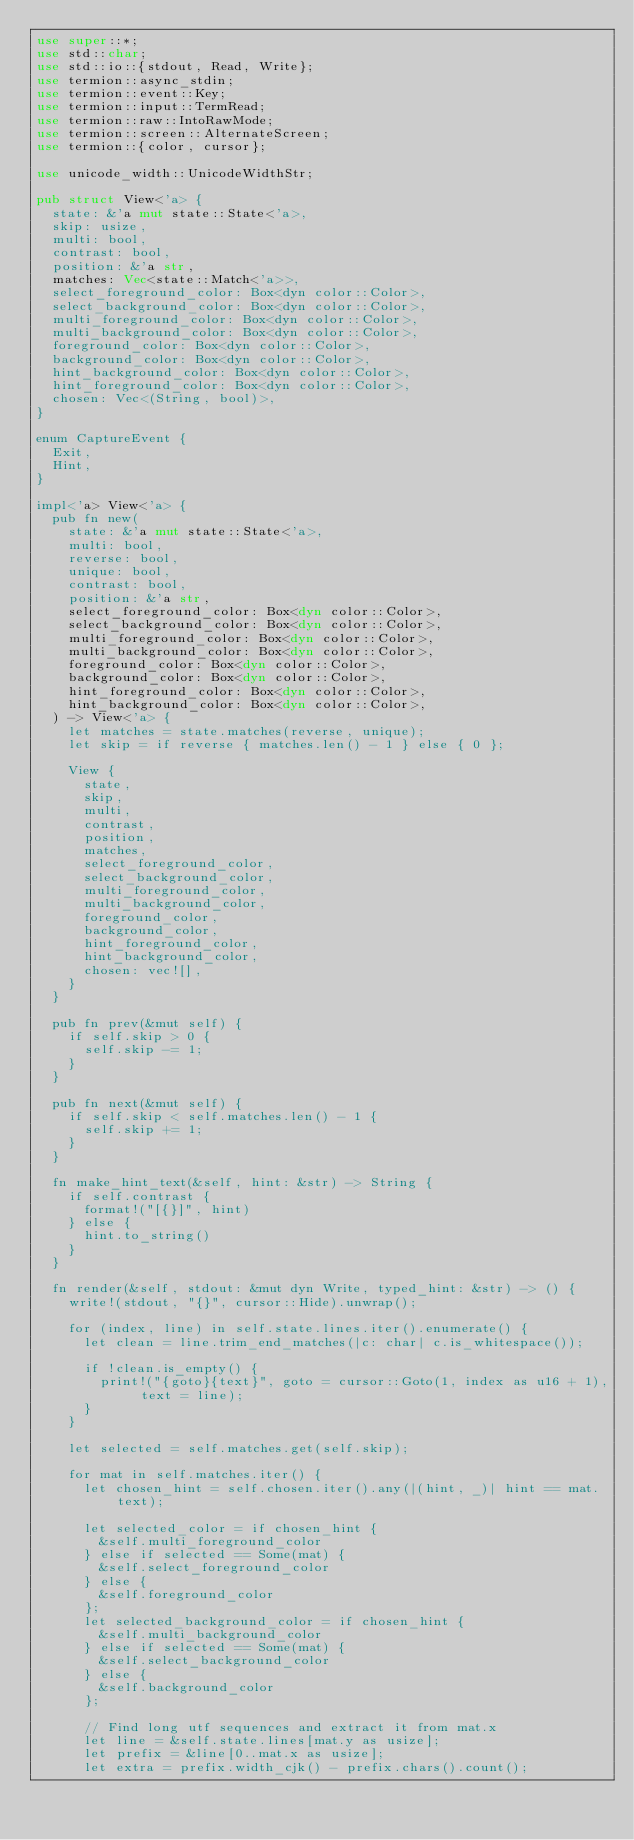<code> <loc_0><loc_0><loc_500><loc_500><_Rust_>use super::*;
use std::char;
use std::io::{stdout, Read, Write};
use termion::async_stdin;
use termion::event::Key;
use termion::input::TermRead;
use termion::raw::IntoRawMode;
use termion::screen::AlternateScreen;
use termion::{color, cursor};

use unicode_width::UnicodeWidthStr;

pub struct View<'a> {
  state: &'a mut state::State<'a>,
  skip: usize,
  multi: bool,
  contrast: bool,
  position: &'a str,
  matches: Vec<state::Match<'a>>,
  select_foreground_color: Box<dyn color::Color>,
  select_background_color: Box<dyn color::Color>,
  multi_foreground_color: Box<dyn color::Color>,
  multi_background_color: Box<dyn color::Color>,
  foreground_color: Box<dyn color::Color>,
  background_color: Box<dyn color::Color>,
  hint_background_color: Box<dyn color::Color>,
  hint_foreground_color: Box<dyn color::Color>,
  chosen: Vec<(String, bool)>,
}

enum CaptureEvent {
  Exit,
  Hint,
}

impl<'a> View<'a> {
  pub fn new(
    state: &'a mut state::State<'a>,
    multi: bool,
    reverse: bool,
    unique: bool,
    contrast: bool,
    position: &'a str,
    select_foreground_color: Box<dyn color::Color>,
    select_background_color: Box<dyn color::Color>,
    multi_foreground_color: Box<dyn color::Color>,
    multi_background_color: Box<dyn color::Color>,
    foreground_color: Box<dyn color::Color>,
    background_color: Box<dyn color::Color>,
    hint_foreground_color: Box<dyn color::Color>,
    hint_background_color: Box<dyn color::Color>,
  ) -> View<'a> {
    let matches = state.matches(reverse, unique);
    let skip = if reverse { matches.len() - 1 } else { 0 };

    View {
      state,
      skip,
      multi,
      contrast,
      position,
      matches,
      select_foreground_color,
      select_background_color,
      multi_foreground_color,
      multi_background_color,
      foreground_color,
      background_color,
      hint_foreground_color,
      hint_background_color,
      chosen: vec![],
    }
  }

  pub fn prev(&mut self) {
    if self.skip > 0 {
      self.skip -= 1;
    }
  }

  pub fn next(&mut self) {
    if self.skip < self.matches.len() - 1 {
      self.skip += 1;
    }
  }

  fn make_hint_text(&self, hint: &str) -> String {
    if self.contrast {
      format!("[{}]", hint)
    } else {
      hint.to_string()
    }
  }

  fn render(&self, stdout: &mut dyn Write, typed_hint: &str) -> () {
    write!(stdout, "{}", cursor::Hide).unwrap();

    for (index, line) in self.state.lines.iter().enumerate() {
      let clean = line.trim_end_matches(|c: char| c.is_whitespace());

      if !clean.is_empty() {
        print!("{goto}{text}", goto = cursor::Goto(1, index as u16 + 1), text = line);
      }
    }

    let selected = self.matches.get(self.skip);

    for mat in self.matches.iter() {
      let chosen_hint = self.chosen.iter().any(|(hint, _)| hint == mat.text);

      let selected_color = if chosen_hint {
        &self.multi_foreground_color
      } else if selected == Some(mat) {
        &self.select_foreground_color
      } else {
        &self.foreground_color
      };
      let selected_background_color = if chosen_hint {
        &self.multi_background_color
      } else if selected == Some(mat) {
        &self.select_background_color
      } else {
        &self.background_color
      };

      // Find long utf sequences and extract it from mat.x
      let line = &self.state.lines[mat.y as usize];
      let prefix = &line[0..mat.x as usize];
      let extra = prefix.width_cjk() - prefix.chars().count();</code> 